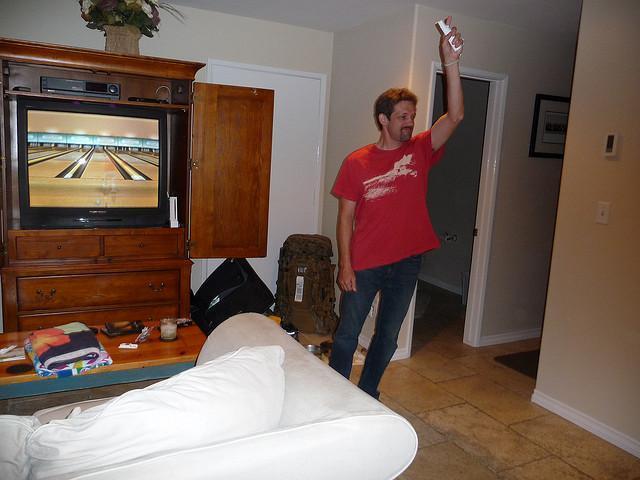How many people are standing?
Give a very brief answer. 1. How many suitcases are there?
Give a very brief answer. 2. How many airplanes are there?
Give a very brief answer. 0. 